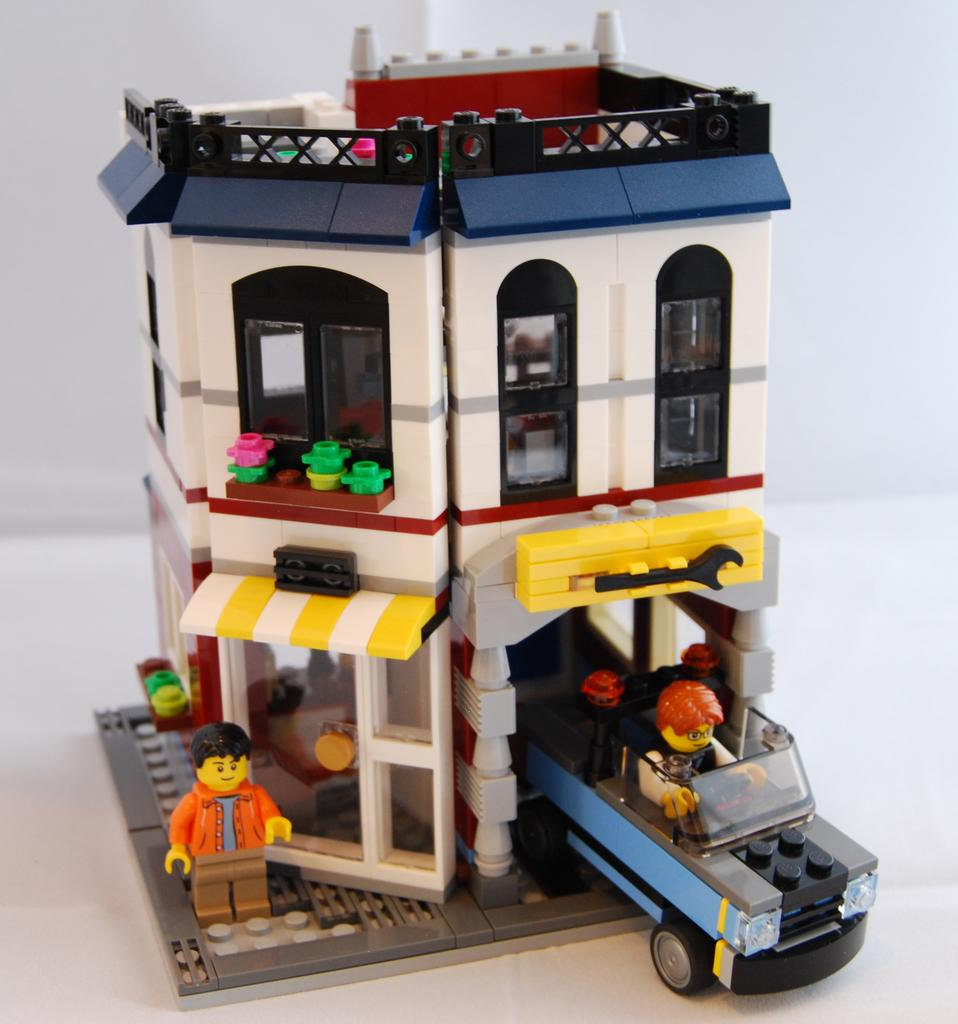What type of instrument is being played in the image, and how does its sound affect the acoustics of the room, measured in centimeters? There is no image provided, so it is impossible to determine the type of instrument being played or the acoustics of the room. 